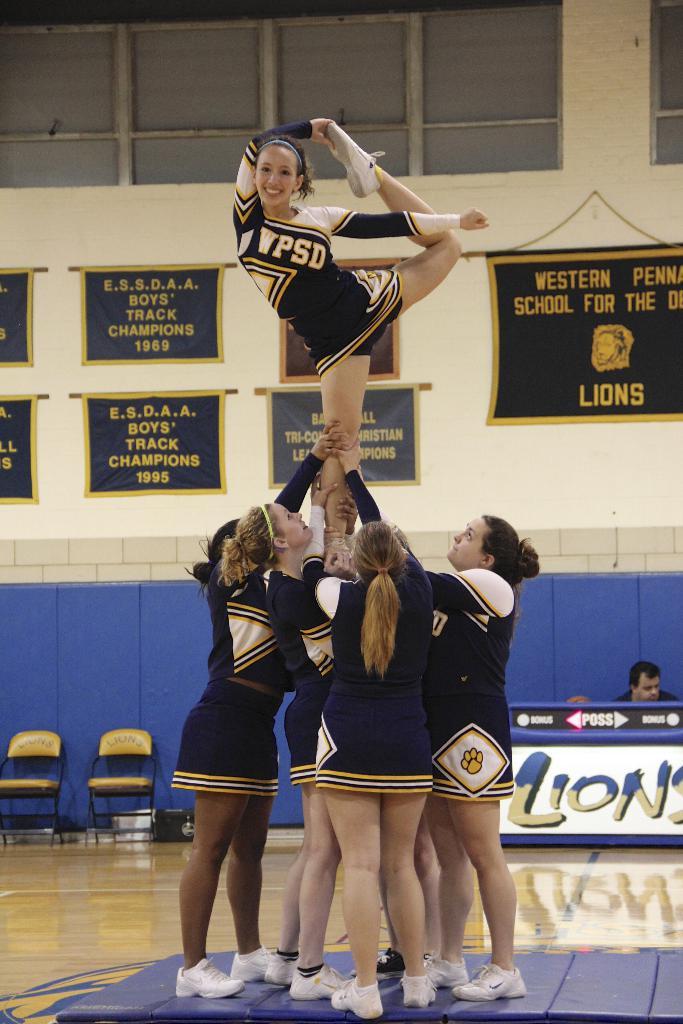What is the team name of the school?
Your response must be concise. Lions. What animal is featured on teh top right banner?
Your response must be concise. Lions. 